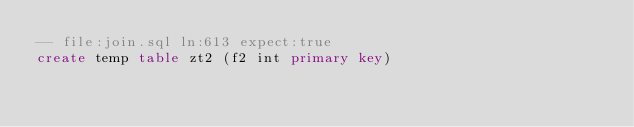<code> <loc_0><loc_0><loc_500><loc_500><_SQL_>-- file:join.sql ln:613 expect:true
create temp table zt2 (f2 int primary key)
</code> 